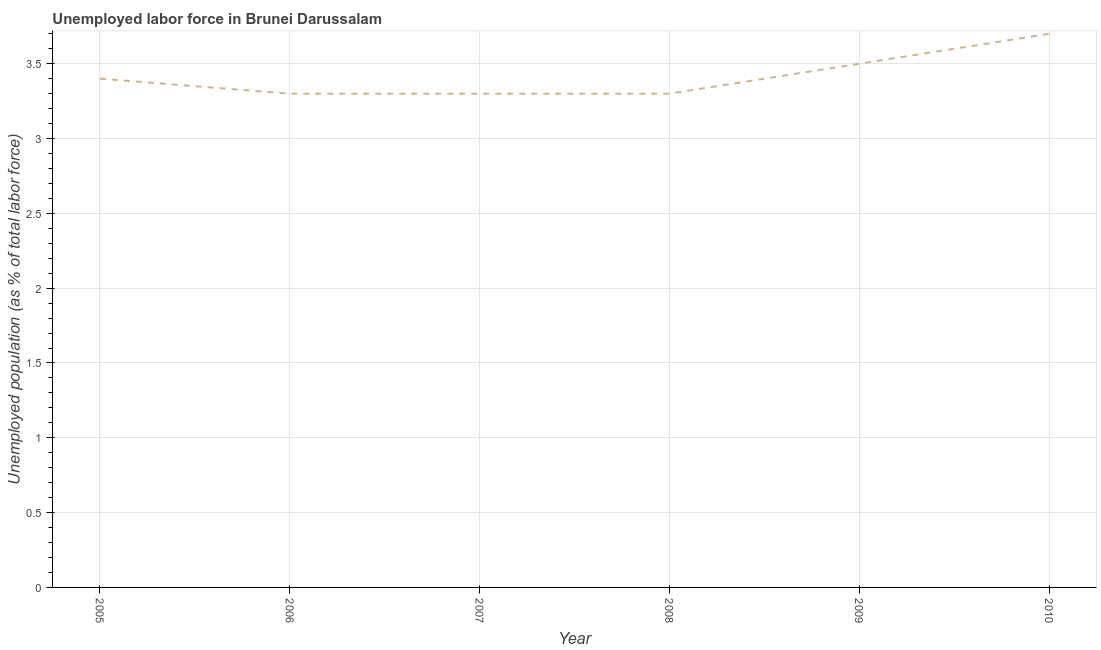What is the total unemployed population in 2007?
Offer a very short reply. 3.3. Across all years, what is the maximum total unemployed population?
Ensure brevity in your answer.  3.7. Across all years, what is the minimum total unemployed population?
Make the answer very short. 3.3. What is the sum of the total unemployed population?
Your answer should be very brief. 20.5. What is the difference between the total unemployed population in 2008 and 2010?
Provide a succinct answer. -0.4. What is the average total unemployed population per year?
Ensure brevity in your answer.  3.42. What is the median total unemployed population?
Offer a very short reply. 3.35. What is the ratio of the total unemployed population in 2007 to that in 2010?
Your answer should be compact. 0.89. Is the total unemployed population in 2005 less than that in 2008?
Keep it short and to the point. No. Is the difference between the total unemployed population in 2005 and 2007 greater than the difference between any two years?
Provide a short and direct response. No. What is the difference between the highest and the second highest total unemployed population?
Keep it short and to the point. 0.2. What is the difference between the highest and the lowest total unemployed population?
Ensure brevity in your answer.  0.4. Does the total unemployed population monotonically increase over the years?
Your response must be concise. No. How many lines are there?
Make the answer very short. 1. How many years are there in the graph?
Keep it short and to the point. 6. Are the values on the major ticks of Y-axis written in scientific E-notation?
Offer a terse response. No. What is the title of the graph?
Ensure brevity in your answer.  Unemployed labor force in Brunei Darussalam. What is the label or title of the Y-axis?
Give a very brief answer. Unemployed population (as % of total labor force). What is the Unemployed population (as % of total labor force) of 2005?
Provide a succinct answer. 3.4. What is the Unemployed population (as % of total labor force) in 2006?
Offer a terse response. 3.3. What is the Unemployed population (as % of total labor force) in 2007?
Give a very brief answer. 3.3. What is the Unemployed population (as % of total labor force) of 2008?
Your answer should be compact. 3.3. What is the Unemployed population (as % of total labor force) of 2010?
Provide a succinct answer. 3.7. What is the difference between the Unemployed population (as % of total labor force) in 2005 and 2009?
Provide a short and direct response. -0.1. What is the difference between the Unemployed population (as % of total labor force) in 2007 and 2009?
Offer a terse response. -0.2. What is the difference between the Unemployed population (as % of total labor force) in 2007 and 2010?
Make the answer very short. -0.4. What is the difference between the Unemployed population (as % of total labor force) in 2008 and 2010?
Provide a succinct answer. -0.4. What is the difference between the Unemployed population (as % of total labor force) in 2009 and 2010?
Provide a short and direct response. -0.2. What is the ratio of the Unemployed population (as % of total labor force) in 2005 to that in 2008?
Your response must be concise. 1.03. What is the ratio of the Unemployed population (as % of total labor force) in 2005 to that in 2010?
Keep it short and to the point. 0.92. What is the ratio of the Unemployed population (as % of total labor force) in 2006 to that in 2007?
Provide a short and direct response. 1. What is the ratio of the Unemployed population (as % of total labor force) in 2006 to that in 2008?
Provide a short and direct response. 1. What is the ratio of the Unemployed population (as % of total labor force) in 2006 to that in 2009?
Offer a very short reply. 0.94. What is the ratio of the Unemployed population (as % of total labor force) in 2006 to that in 2010?
Your answer should be very brief. 0.89. What is the ratio of the Unemployed population (as % of total labor force) in 2007 to that in 2008?
Provide a succinct answer. 1. What is the ratio of the Unemployed population (as % of total labor force) in 2007 to that in 2009?
Ensure brevity in your answer.  0.94. What is the ratio of the Unemployed population (as % of total labor force) in 2007 to that in 2010?
Provide a short and direct response. 0.89. What is the ratio of the Unemployed population (as % of total labor force) in 2008 to that in 2009?
Give a very brief answer. 0.94. What is the ratio of the Unemployed population (as % of total labor force) in 2008 to that in 2010?
Your answer should be very brief. 0.89. What is the ratio of the Unemployed population (as % of total labor force) in 2009 to that in 2010?
Ensure brevity in your answer.  0.95. 